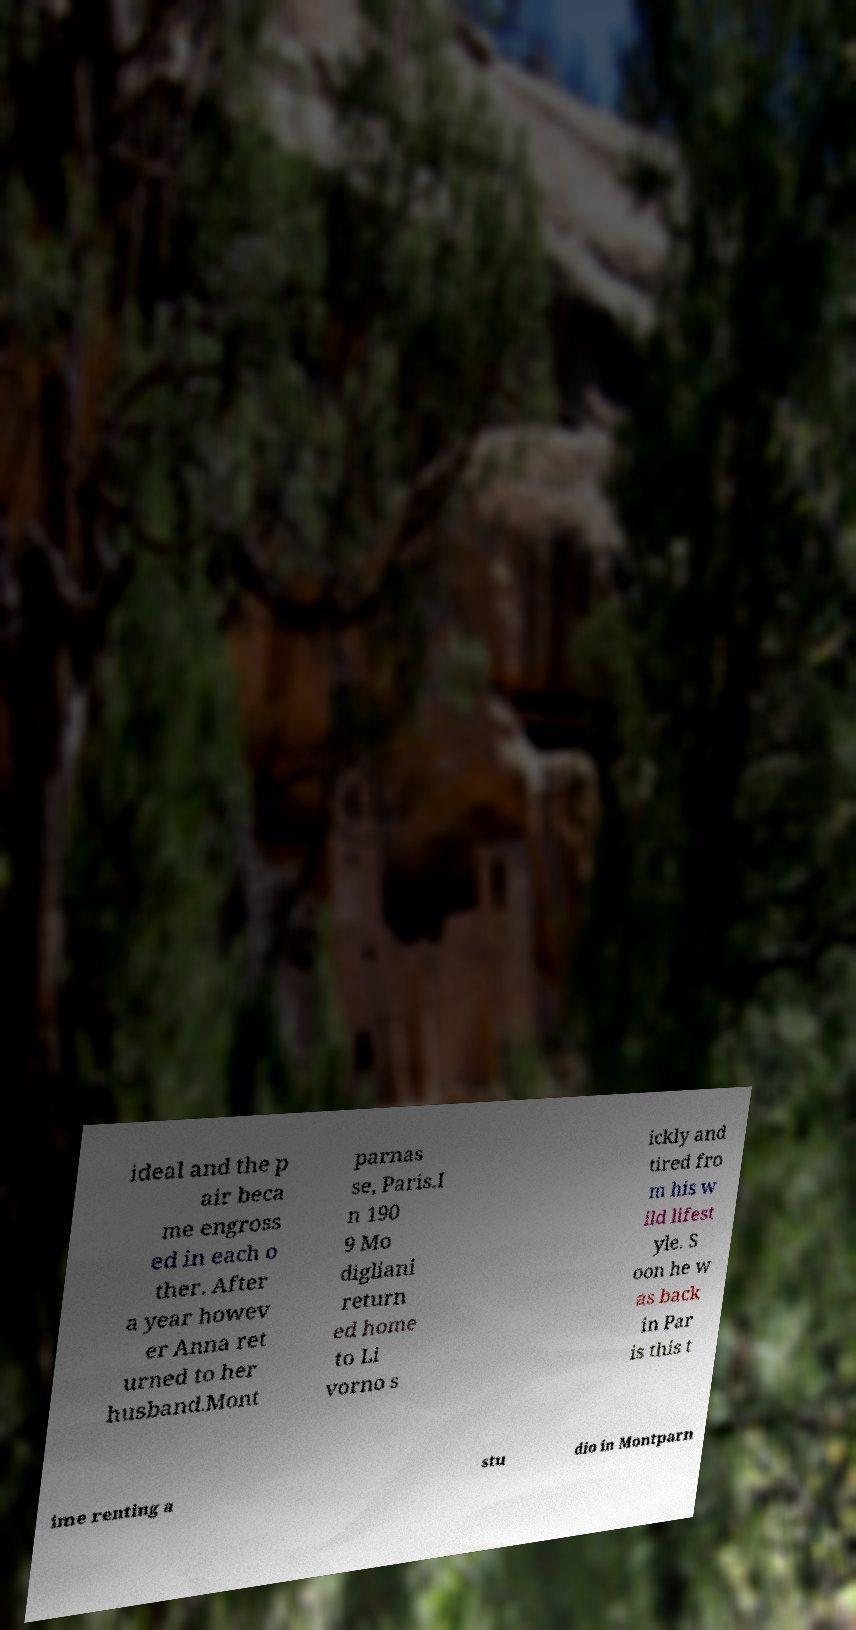There's text embedded in this image that I need extracted. Can you transcribe it verbatim? ideal and the p air beca me engross ed in each o ther. After a year howev er Anna ret urned to her husband.Mont parnas se, Paris.I n 190 9 Mo digliani return ed home to Li vorno s ickly and tired fro m his w ild lifest yle. S oon he w as back in Par is this t ime renting a stu dio in Montparn 